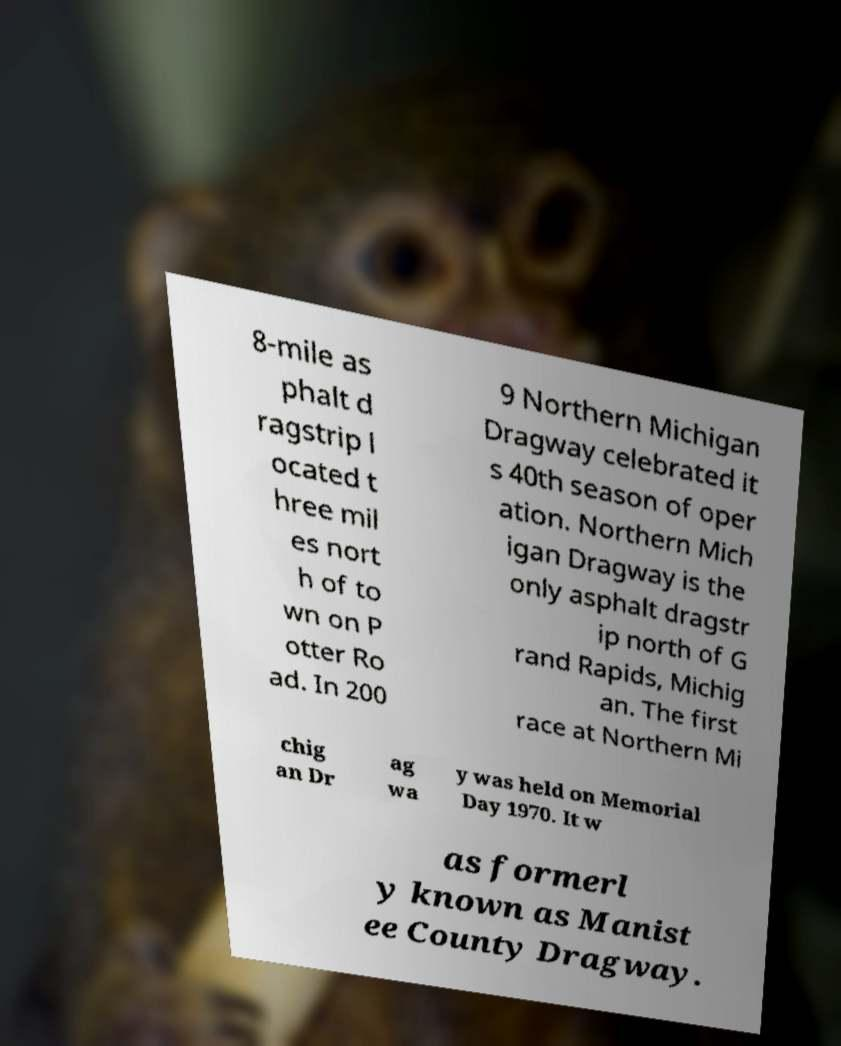Could you assist in decoding the text presented in this image and type it out clearly? 8-mile as phalt d ragstrip l ocated t hree mil es nort h of to wn on P otter Ro ad. In 200 9 Northern Michigan Dragway celebrated it s 40th season of oper ation. Northern Mich igan Dragway is the only asphalt dragstr ip north of G rand Rapids, Michig an. The first race at Northern Mi chig an Dr ag wa y was held on Memorial Day 1970. It w as formerl y known as Manist ee County Dragway. 